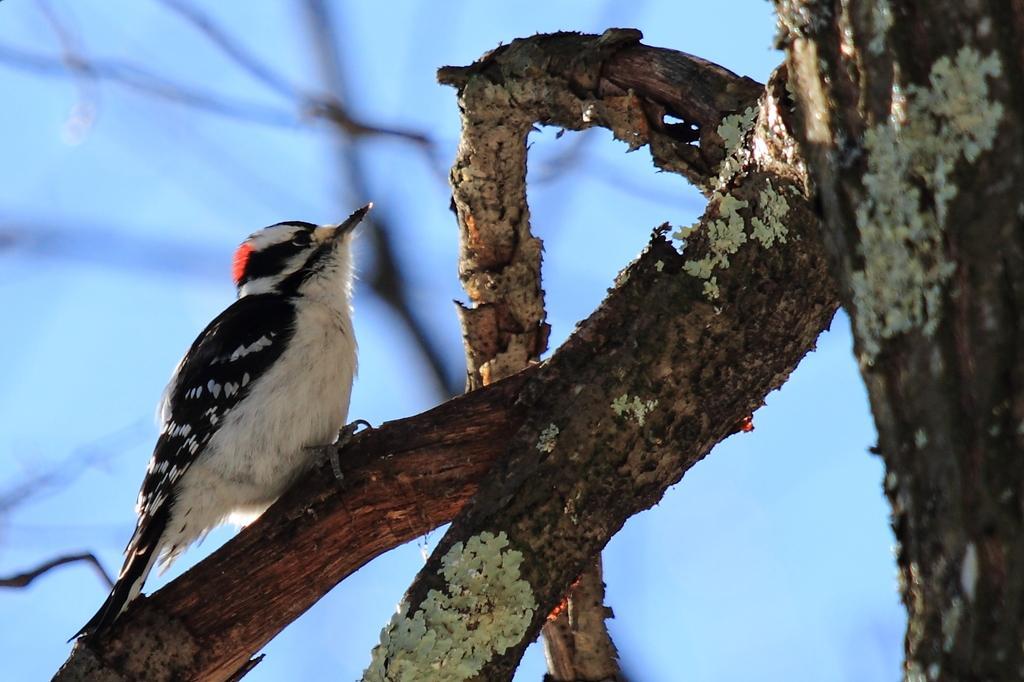Please provide a concise description of this image. In this image we can see there is a bird on the tree. 